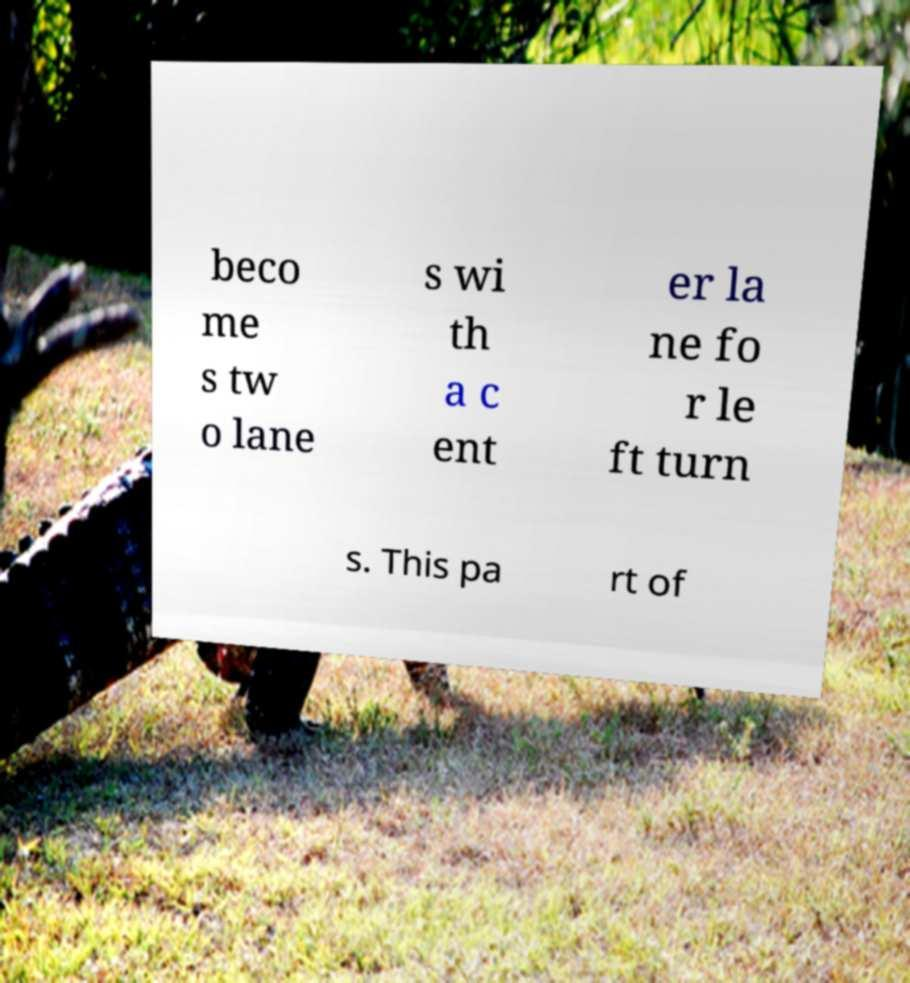I need the written content from this picture converted into text. Can you do that? beco me s tw o lane s wi th a c ent er la ne fo r le ft turn s. This pa rt of 